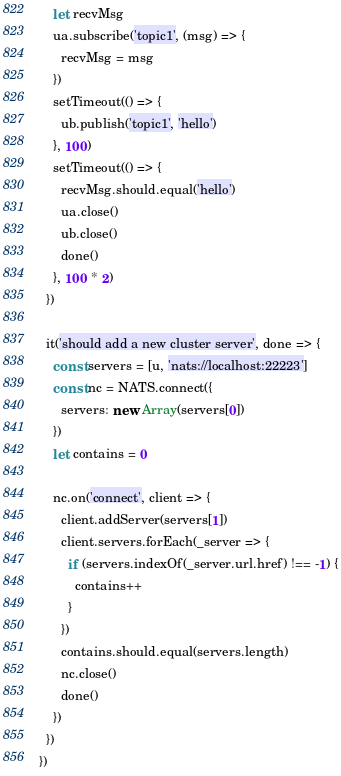Convert code to text. <code><loc_0><loc_0><loc_500><loc_500><_JavaScript_>    let recvMsg
    ua.subscribe('topic1', (msg) => {
      recvMsg = msg
    })
    setTimeout(() => {
      ub.publish('topic1', 'hello')
    }, 100)
    setTimeout(() => {
      recvMsg.should.equal('hello')
      ua.close()
      ub.close()
      done()
    }, 100 * 2)
  })

  it('should add a new cluster server', done => {
    const servers = [u, 'nats://localhost:22223']
    const nc = NATS.connect({
      servers: new Array(servers[0])
    })
    let contains = 0

    nc.on('connect', client => {
      client.addServer(servers[1])
      client.servers.forEach(_server => {
        if (servers.indexOf(_server.url.href) !== -1) {
          contains++
        }
      })
      contains.should.equal(servers.length)
      nc.close()
      done()
    })
  })
})
</code> 